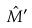<formula> <loc_0><loc_0><loc_500><loc_500>\hat { M } ^ { \prime }</formula> 